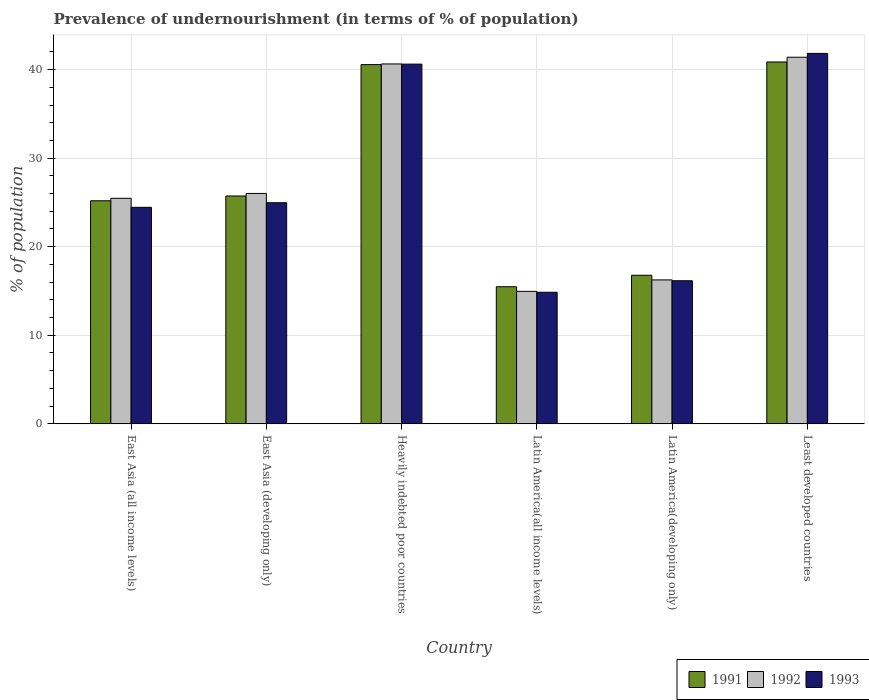How many different coloured bars are there?
Make the answer very short. 3. Are the number of bars on each tick of the X-axis equal?
Provide a short and direct response. Yes. What is the label of the 4th group of bars from the left?
Provide a succinct answer. Latin America(all income levels). What is the percentage of undernourished population in 1991 in East Asia (developing only)?
Your response must be concise. 25.73. Across all countries, what is the maximum percentage of undernourished population in 1991?
Give a very brief answer. 40.86. Across all countries, what is the minimum percentage of undernourished population in 1991?
Your answer should be very brief. 15.48. In which country was the percentage of undernourished population in 1992 maximum?
Offer a terse response. Least developed countries. In which country was the percentage of undernourished population in 1991 minimum?
Provide a short and direct response. Latin America(all income levels). What is the total percentage of undernourished population in 1993 in the graph?
Offer a very short reply. 162.87. What is the difference between the percentage of undernourished population in 1991 in Latin America(all income levels) and that in Least developed countries?
Make the answer very short. -25.39. What is the difference between the percentage of undernourished population in 1991 in East Asia (all income levels) and the percentage of undernourished population in 1993 in East Asia (developing only)?
Give a very brief answer. 0.22. What is the average percentage of undernourished population in 1992 per country?
Offer a terse response. 27.45. What is the difference between the percentage of undernourished population of/in 1991 and percentage of undernourished population of/in 1992 in Least developed countries?
Offer a very short reply. -0.54. What is the ratio of the percentage of undernourished population in 1992 in Heavily indebted poor countries to that in Latin America(developing only)?
Offer a very short reply. 2.5. Is the percentage of undernourished population in 1993 in East Asia (developing only) less than that in Latin America(all income levels)?
Ensure brevity in your answer.  No. Is the difference between the percentage of undernourished population in 1991 in East Asia (all income levels) and Heavily indebted poor countries greater than the difference between the percentage of undernourished population in 1992 in East Asia (all income levels) and Heavily indebted poor countries?
Provide a short and direct response. No. What is the difference between the highest and the second highest percentage of undernourished population in 1992?
Offer a very short reply. -0.76. What is the difference between the highest and the lowest percentage of undernourished population in 1993?
Offer a terse response. 26.98. Is the sum of the percentage of undernourished population in 1992 in Latin America(developing only) and Least developed countries greater than the maximum percentage of undernourished population in 1993 across all countries?
Ensure brevity in your answer.  Yes. What does the 2nd bar from the left in East Asia (all income levels) represents?
Provide a succinct answer. 1992. What does the 1st bar from the right in Heavily indebted poor countries represents?
Your response must be concise. 1993. How many bars are there?
Your answer should be very brief. 18. How many countries are there in the graph?
Make the answer very short. 6. Does the graph contain grids?
Your response must be concise. Yes. How many legend labels are there?
Provide a short and direct response. 3. What is the title of the graph?
Offer a very short reply. Prevalence of undernourishment (in terms of % of population). Does "2009" appear as one of the legend labels in the graph?
Ensure brevity in your answer.  No. What is the label or title of the X-axis?
Offer a terse response. Country. What is the label or title of the Y-axis?
Offer a very short reply. % of population. What is the % of population of 1991 in East Asia (all income levels)?
Offer a very short reply. 25.19. What is the % of population in 1992 in East Asia (all income levels)?
Provide a short and direct response. 25.47. What is the % of population of 1993 in East Asia (all income levels)?
Offer a terse response. 24.45. What is the % of population in 1991 in East Asia (developing only)?
Your answer should be very brief. 25.73. What is the % of population in 1992 in East Asia (developing only)?
Make the answer very short. 26.01. What is the % of population in 1993 in East Asia (developing only)?
Your response must be concise. 24.97. What is the % of population of 1991 in Heavily indebted poor countries?
Your response must be concise. 40.57. What is the % of population in 1992 in Heavily indebted poor countries?
Give a very brief answer. 40.64. What is the % of population of 1993 in Heavily indebted poor countries?
Give a very brief answer. 40.62. What is the % of population in 1991 in Latin America(all income levels)?
Your answer should be compact. 15.48. What is the % of population of 1992 in Latin America(all income levels)?
Make the answer very short. 14.96. What is the % of population in 1993 in Latin America(all income levels)?
Keep it short and to the point. 14.85. What is the % of population of 1991 in Latin America(developing only)?
Give a very brief answer. 16.77. What is the % of population of 1992 in Latin America(developing only)?
Your answer should be very brief. 16.25. What is the % of population of 1993 in Latin America(developing only)?
Provide a succinct answer. 16.15. What is the % of population in 1991 in Least developed countries?
Offer a very short reply. 40.86. What is the % of population in 1992 in Least developed countries?
Ensure brevity in your answer.  41.4. What is the % of population in 1993 in Least developed countries?
Keep it short and to the point. 41.83. Across all countries, what is the maximum % of population in 1991?
Offer a very short reply. 40.86. Across all countries, what is the maximum % of population of 1992?
Offer a very short reply. 41.4. Across all countries, what is the maximum % of population of 1993?
Provide a short and direct response. 41.83. Across all countries, what is the minimum % of population in 1991?
Ensure brevity in your answer.  15.48. Across all countries, what is the minimum % of population in 1992?
Your answer should be compact. 14.96. Across all countries, what is the minimum % of population in 1993?
Keep it short and to the point. 14.85. What is the total % of population in 1991 in the graph?
Keep it short and to the point. 164.6. What is the total % of population of 1992 in the graph?
Make the answer very short. 164.73. What is the total % of population in 1993 in the graph?
Offer a very short reply. 162.87. What is the difference between the % of population in 1991 in East Asia (all income levels) and that in East Asia (developing only)?
Ensure brevity in your answer.  -0.54. What is the difference between the % of population of 1992 in East Asia (all income levels) and that in East Asia (developing only)?
Your response must be concise. -0.55. What is the difference between the % of population in 1993 in East Asia (all income levels) and that in East Asia (developing only)?
Your answer should be very brief. -0.52. What is the difference between the % of population of 1991 in East Asia (all income levels) and that in Heavily indebted poor countries?
Your response must be concise. -15.38. What is the difference between the % of population in 1992 in East Asia (all income levels) and that in Heavily indebted poor countries?
Keep it short and to the point. -15.18. What is the difference between the % of population in 1993 in East Asia (all income levels) and that in Heavily indebted poor countries?
Keep it short and to the point. -16.18. What is the difference between the % of population in 1991 in East Asia (all income levels) and that in Latin America(all income levels)?
Offer a terse response. 9.71. What is the difference between the % of population of 1992 in East Asia (all income levels) and that in Latin America(all income levels)?
Offer a very short reply. 10.51. What is the difference between the % of population of 1993 in East Asia (all income levels) and that in Latin America(all income levels)?
Give a very brief answer. 9.6. What is the difference between the % of population of 1991 in East Asia (all income levels) and that in Latin America(developing only)?
Ensure brevity in your answer.  8.41. What is the difference between the % of population of 1992 in East Asia (all income levels) and that in Latin America(developing only)?
Provide a short and direct response. 9.22. What is the difference between the % of population of 1993 in East Asia (all income levels) and that in Latin America(developing only)?
Offer a terse response. 8.29. What is the difference between the % of population of 1991 in East Asia (all income levels) and that in Least developed countries?
Give a very brief answer. -15.68. What is the difference between the % of population of 1992 in East Asia (all income levels) and that in Least developed countries?
Ensure brevity in your answer.  -15.94. What is the difference between the % of population of 1993 in East Asia (all income levels) and that in Least developed countries?
Provide a short and direct response. -17.39. What is the difference between the % of population of 1991 in East Asia (developing only) and that in Heavily indebted poor countries?
Make the answer very short. -14.84. What is the difference between the % of population in 1992 in East Asia (developing only) and that in Heavily indebted poor countries?
Your response must be concise. -14.63. What is the difference between the % of population in 1993 in East Asia (developing only) and that in Heavily indebted poor countries?
Ensure brevity in your answer.  -15.66. What is the difference between the % of population of 1991 in East Asia (developing only) and that in Latin America(all income levels)?
Offer a terse response. 10.25. What is the difference between the % of population of 1992 in East Asia (developing only) and that in Latin America(all income levels)?
Your answer should be very brief. 11.06. What is the difference between the % of population in 1993 in East Asia (developing only) and that in Latin America(all income levels)?
Your answer should be very brief. 10.11. What is the difference between the % of population in 1991 in East Asia (developing only) and that in Latin America(developing only)?
Give a very brief answer. 8.95. What is the difference between the % of population of 1992 in East Asia (developing only) and that in Latin America(developing only)?
Offer a very short reply. 9.77. What is the difference between the % of population of 1993 in East Asia (developing only) and that in Latin America(developing only)?
Give a very brief answer. 8.81. What is the difference between the % of population in 1991 in East Asia (developing only) and that in Least developed countries?
Your response must be concise. -15.14. What is the difference between the % of population in 1992 in East Asia (developing only) and that in Least developed countries?
Make the answer very short. -15.39. What is the difference between the % of population in 1993 in East Asia (developing only) and that in Least developed countries?
Offer a very short reply. -16.87. What is the difference between the % of population of 1991 in Heavily indebted poor countries and that in Latin America(all income levels)?
Your answer should be very brief. 25.09. What is the difference between the % of population of 1992 in Heavily indebted poor countries and that in Latin America(all income levels)?
Ensure brevity in your answer.  25.69. What is the difference between the % of population in 1993 in Heavily indebted poor countries and that in Latin America(all income levels)?
Keep it short and to the point. 25.77. What is the difference between the % of population of 1991 in Heavily indebted poor countries and that in Latin America(developing only)?
Make the answer very short. 23.8. What is the difference between the % of population in 1992 in Heavily indebted poor countries and that in Latin America(developing only)?
Provide a succinct answer. 24.4. What is the difference between the % of population in 1993 in Heavily indebted poor countries and that in Latin America(developing only)?
Offer a very short reply. 24.47. What is the difference between the % of population in 1991 in Heavily indebted poor countries and that in Least developed countries?
Provide a succinct answer. -0.3. What is the difference between the % of population in 1992 in Heavily indebted poor countries and that in Least developed countries?
Keep it short and to the point. -0.76. What is the difference between the % of population in 1993 in Heavily indebted poor countries and that in Least developed countries?
Offer a very short reply. -1.21. What is the difference between the % of population of 1991 in Latin America(all income levels) and that in Latin America(developing only)?
Ensure brevity in your answer.  -1.3. What is the difference between the % of population of 1992 in Latin America(all income levels) and that in Latin America(developing only)?
Your response must be concise. -1.29. What is the difference between the % of population of 1993 in Latin America(all income levels) and that in Latin America(developing only)?
Your response must be concise. -1.3. What is the difference between the % of population of 1991 in Latin America(all income levels) and that in Least developed countries?
Your answer should be compact. -25.39. What is the difference between the % of population of 1992 in Latin America(all income levels) and that in Least developed countries?
Keep it short and to the point. -26.45. What is the difference between the % of population in 1993 in Latin America(all income levels) and that in Least developed countries?
Your answer should be very brief. -26.98. What is the difference between the % of population of 1991 in Latin America(developing only) and that in Least developed countries?
Offer a terse response. -24.09. What is the difference between the % of population in 1992 in Latin America(developing only) and that in Least developed countries?
Provide a short and direct response. -25.16. What is the difference between the % of population of 1993 in Latin America(developing only) and that in Least developed countries?
Offer a very short reply. -25.68. What is the difference between the % of population of 1991 in East Asia (all income levels) and the % of population of 1992 in East Asia (developing only)?
Keep it short and to the point. -0.83. What is the difference between the % of population of 1991 in East Asia (all income levels) and the % of population of 1993 in East Asia (developing only)?
Your answer should be compact. 0.22. What is the difference between the % of population of 1992 in East Asia (all income levels) and the % of population of 1993 in East Asia (developing only)?
Your response must be concise. 0.5. What is the difference between the % of population in 1991 in East Asia (all income levels) and the % of population in 1992 in Heavily indebted poor countries?
Ensure brevity in your answer.  -15.46. What is the difference between the % of population of 1991 in East Asia (all income levels) and the % of population of 1993 in Heavily indebted poor countries?
Make the answer very short. -15.44. What is the difference between the % of population of 1992 in East Asia (all income levels) and the % of population of 1993 in Heavily indebted poor countries?
Ensure brevity in your answer.  -15.16. What is the difference between the % of population in 1991 in East Asia (all income levels) and the % of population in 1992 in Latin America(all income levels)?
Give a very brief answer. 10.23. What is the difference between the % of population of 1991 in East Asia (all income levels) and the % of population of 1993 in Latin America(all income levels)?
Give a very brief answer. 10.33. What is the difference between the % of population of 1992 in East Asia (all income levels) and the % of population of 1993 in Latin America(all income levels)?
Your answer should be very brief. 10.62. What is the difference between the % of population in 1991 in East Asia (all income levels) and the % of population in 1992 in Latin America(developing only)?
Your response must be concise. 8.94. What is the difference between the % of population in 1991 in East Asia (all income levels) and the % of population in 1993 in Latin America(developing only)?
Provide a short and direct response. 9.03. What is the difference between the % of population in 1992 in East Asia (all income levels) and the % of population in 1993 in Latin America(developing only)?
Your response must be concise. 9.31. What is the difference between the % of population of 1991 in East Asia (all income levels) and the % of population of 1992 in Least developed countries?
Give a very brief answer. -16.22. What is the difference between the % of population in 1991 in East Asia (all income levels) and the % of population in 1993 in Least developed countries?
Your response must be concise. -16.65. What is the difference between the % of population in 1992 in East Asia (all income levels) and the % of population in 1993 in Least developed countries?
Ensure brevity in your answer.  -16.37. What is the difference between the % of population in 1991 in East Asia (developing only) and the % of population in 1992 in Heavily indebted poor countries?
Make the answer very short. -14.91. What is the difference between the % of population in 1991 in East Asia (developing only) and the % of population in 1993 in Heavily indebted poor countries?
Your answer should be compact. -14.9. What is the difference between the % of population of 1992 in East Asia (developing only) and the % of population of 1993 in Heavily indebted poor countries?
Offer a very short reply. -14.61. What is the difference between the % of population of 1991 in East Asia (developing only) and the % of population of 1992 in Latin America(all income levels)?
Your answer should be very brief. 10.77. What is the difference between the % of population in 1991 in East Asia (developing only) and the % of population in 1993 in Latin America(all income levels)?
Your answer should be very brief. 10.88. What is the difference between the % of population in 1992 in East Asia (developing only) and the % of population in 1993 in Latin America(all income levels)?
Ensure brevity in your answer.  11.16. What is the difference between the % of population of 1991 in East Asia (developing only) and the % of population of 1992 in Latin America(developing only)?
Your answer should be very brief. 9.48. What is the difference between the % of population of 1991 in East Asia (developing only) and the % of population of 1993 in Latin America(developing only)?
Make the answer very short. 9.58. What is the difference between the % of population in 1992 in East Asia (developing only) and the % of population in 1993 in Latin America(developing only)?
Give a very brief answer. 9.86. What is the difference between the % of population in 1991 in East Asia (developing only) and the % of population in 1992 in Least developed countries?
Offer a terse response. -15.67. What is the difference between the % of population of 1991 in East Asia (developing only) and the % of population of 1993 in Least developed countries?
Ensure brevity in your answer.  -16.11. What is the difference between the % of population in 1992 in East Asia (developing only) and the % of population in 1993 in Least developed countries?
Ensure brevity in your answer.  -15.82. What is the difference between the % of population in 1991 in Heavily indebted poor countries and the % of population in 1992 in Latin America(all income levels)?
Give a very brief answer. 25.61. What is the difference between the % of population of 1991 in Heavily indebted poor countries and the % of population of 1993 in Latin America(all income levels)?
Your response must be concise. 25.72. What is the difference between the % of population of 1992 in Heavily indebted poor countries and the % of population of 1993 in Latin America(all income levels)?
Provide a succinct answer. 25.79. What is the difference between the % of population of 1991 in Heavily indebted poor countries and the % of population of 1992 in Latin America(developing only)?
Keep it short and to the point. 24.32. What is the difference between the % of population of 1991 in Heavily indebted poor countries and the % of population of 1993 in Latin America(developing only)?
Keep it short and to the point. 24.42. What is the difference between the % of population of 1992 in Heavily indebted poor countries and the % of population of 1993 in Latin America(developing only)?
Ensure brevity in your answer.  24.49. What is the difference between the % of population of 1991 in Heavily indebted poor countries and the % of population of 1992 in Least developed countries?
Give a very brief answer. -0.83. What is the difference between the % of population in 1991 in Heavily indebted poor countries and the % of population in 1993 in Least developed countries?
Ensure brevity in your answer.  -1.27. What is the difference between the % of population of 1992 in Heavily indebted poor countries and the % of population of 1993 in Least developed countries?
Give a very brief answer. -1.19. What is the difference between the % of population in 1991 in Latin America(all income levels) and the % of population in 1992 in Latin America(developing only)?
Your response must be concise. -0.77. What is the difference between the % of population of 1991 in Latin America(all income levels) and the % of population of 1993 in Latin America(developing only)?
Offer a terse response. -0.68. What is the difference between the % of population in 1992 in Latin America(all income levels) and the % of population in 1993 in Latin America(developing only)?
Your response must be concise. -1.2. What is the difference between the % of population of 1991 in Latin America(all income levels) and the % of population of 1992 in Least developed countries?
Your answer should be very brief. -25.93. What is the difference between the % of population in 1991 in Latin America(all income levels) and the % of population in 1993 in Least developed countries?
Keep it short and to the point. -26.36. What is the difference between the % of population of 1992 in Latin America(all income levels) and the % of population of 1993 in Least developed countries?
Offer a terse response. -26.88. What is the difference between the % of population of 1991 in Latin America(developing only) and the % of population of 1992 in Least developed countries?
Make the answer very short. -24.63. What is the difference between the % of population of 1991 in Latin America(developing only) and the % of population of 1993 in Least developed countries?
Provide a short and direct response. -25.06. What is the difference between the % of population in 1992 in Latin America(developing only) and the % of population in 1993 in Least developed countries?
Make the answer very short. -25.59. What is the average % of population of 1991 per country?
Your response must be concise. 27.43. What is the average % of population of 1992 per country?
Keep it short and to the point. 27.45. What is the average % of population of 1993 per country?
Keep it short and to the point. 27.15. What is the difference between the % of population of 1991 and % of population of 1992 in East Asia (all income levels)?
Ensure brevity in your answer.  -0.28. What is the difference between the % of population of 1991 and % of population of 1993 in East Asia (all income levels)?
Your response must be concise. 0.74. What is the difference between the % of population of 1991 and % of population of 1992 in East Asia (developing only)?
Offer a terse response. -0.29. What is the difference between the % of population of 1991 and % of population of 1993 in East Asia (developing only)?
Your answer should be very brief. 0.76. What is the difference between the % of population in 1992 and % of population in 1993 in East Asia (developing only)?
Give a very brief answer. 1.05. What is the difference between the % of population of 1991 and % of population of 1992 in Heavily indebted poor countries?
Your answer should be compact. -0.07. What is the difference between the % of population of 1991 and % of population of 1993 in Heavily indebted poor countries?
Your response must be concise. -0.05. What is the difference between the % of population in 1992 and % of population in 1993 in Heavily indebted poor countries?
Ensure brevity in your answer.  0.02. What is the difference between the % of population in 1991 and % of population in 1992 in Latin America(all income levels)?
Ensure brevity in your answer.  0.52. What is the difference between the % of population in 1991 and % of population in 1993 in Latin America(all income levels)?
Your response must be concise. 0.62. What is the difference between the % of population of 1992 and % of population of 1993 in Latin America(all income levels)?
Provide a short and direct response. 0.1. What is the difference between the % of population in 1991 and % of population in 1992 in Latin America(developing only)?
Offer a terse response. 0.53. What is the difference between the % of population of 1991 and % of population of 1993 in Latin America(developing only)?
Provide a short and direct response. 0.62. What is the difference between the % of population of 1992 and % of population of 1993 in Latin America(developing only)?
Give a very brief answer. 0.09. What is the difference between the % of population in 1991 and % of population in 1992 in Least developed countries?
Offer a terse response. -0.54. What is the difference between the % of population in 1991 and % of population in 1993 in Least developed countries?
Keep it short and to the point. -0.97. What is the difference between the % of population of 1992 and % of population of 1993 in Least developed countries?
Ensure brevity in your answer.  -0.43. What is the ratio of the % of population of 1991 in East Asia (all income levels) to that in East Asia (developing only)?
Your answer should be very brief. 0.98. What is the ratio of the % of population in 1992 in East Asia (all income levels) to that in East Asia (developing only)?
Ensure brevity in your answer.  0.98. What is the ratio of the % of population of 1993 in East Asia (all income levels) to that in East Asia (developing only)?
Make the answer very short. 0.98. What is the ratio of the % of population of 1991 in East Asia (all income levels) to that in Heavily indebted poor countries?
Keep it short and to the point. 0.62. What is the ratio of the % of population of 1992 in East Asia (all income levels) to that in Heavily indebted poor countries?
Your answer should be very brief. 0.63. What is the ratio of the % of population of 1993 in East Asia (all income levels) to that in Heavily indebted poor countries?
Your answer should be compact. 0.6. What is the ratio of the % of population of 1991 in East Asia (all income levels) to that in Latin America(all income levels)?
Provide a short and direct response. 1.63. What is the ratio of the % of population of 1992 in East Asia (all income levels) to that in Latin America(all income levels)?
Your answer should be very brief. 1.7. What is the ratio of the % of population in 1993 in East Asia (all income levels) to that in Latin America(all income levels)?
Your answer should be very brief. 1.65. What is the ratio of the % of population of 1991 in East Asia (all income levels) to that in Latin America(developing only)?
Ensure brevity in your answer.  1.5. What is the ratio of the % of population of 1992 in East Asia (all income levels) to that in Latin America(developing only)?
Your answer should be very brief. 1.57. What is the ratio of the % of population of 1993 in East Asia (all income levels) to that in Latin America(developing only)?
Give a very brief answer. 1.51. What is the ratio of the % of population of 1991 in East Asia (all income levels) to that in Least developed countries?
Provide a short and direct response. 0.62. What is the ratio of the % of population of 1992 in East Asia (all income levels) to that in Least developed countries?
Make the answer very short. 0.62. What is the ratio of the % of population in 1993 in East Asia (all income levels) to that in Least developed countries?
Ensure brevity in your answer.  0.58. What is the ratio of the % of population of 1991 in East Asia (developing only) to that in Heavily indebted poor countries?
Your answer should be very brief. 0.63. What is the ratio of the % of population of 1992 in East Asia (developing only) to that in Heavily indebted poor countries?
Provide a short and direct response. 0.64. What is the ratio of the % of population in 1993 in East Asia (developing only) to that in Heavily indebted poor countries?
Your answer should be very brief. 0.61. What is the ratio of the % of population of 1991 in East Asia (developing only) to that in Latin America(all income levels)?
Ensure brevity in your answer.  1.66. What is the ratio of the % of population of 1992 in East Asia (developing only) to that in Latin America(all income levels)?
Offer a very short reply. 1.74. What is the ratio of the % of population in 1993 in East Asia (developing only) to that in Latin America(all income levels)?
Your answer should be compact. 1.68. What is the ratio of the % of population of 1991 in East Asia (developing only) to that in Latin America(developing only)?
Offer a very short reply. 1.53. What is the ratio of the % of population of 1992 in East Asia (developing only) to that in Latin America(developing only)?
Make the answer very short. 1.6. What is the ratio of the % of population in 1993 in East Asia (developing only) to that in Latin America(developing only)?
Make the answer very short. 1.55. What is the ratio of the % of population of 1991 in East Asia (developing only) to that in Least developed countries?
Provide a short and direct response. 0.63. What is the ratio of the % of population in 1992 in East Asia (developing only) to that in Least developed countries?
Your answer should be very brief. 0.63. What is the ratio of the % of population of 1993 in East Asia (developing only) to that in Least developed countries?
Give a very brief answer. 0.6. What is the ratio of the % of population of 1991 in Heavily indebted poor countries to that in Latin America(all income levels)?
Make the answer very short. 2.62. What is the ratio of the % of population in 1992 in Heavily indebted poor countries to that in Latin America(all income levels)?
Your answer should be very brief. 2.72. What is the ratio of the % of population in 1993 in Heavily indebted poor countries to that in Latin America(all income levels)?
Make the answer very short. 2.74. What is the ratio of the % of population in 1991 in Heavily indebted poor countries to that in Latin America(developing only)?
Ensure brevity in your answer.  2.42. What is the ratio of the % of population in 1992 in Heavily indebted poor countries to that in Latin America(developing only)?
Offer a terse response. 2.5. What is the ratio of the % of population of 1993 in Heavily indebted poor countries to that in Latin America(developing only)?
Your answer should be compact. 2.52. What is the ratio of the % of population in 1991 in Heavily indebted poor countries to that in Least developed countries?
Give a very brief answer. 0.99. What is the ratio of the % of population of 1992 in Heavily indebted poor countries to that in Least developed countries?
Your answer should be compact. 0.98. What is the ratio of the % of population in 1993 in Heavily indebted poor countries to that in Least developed countries?
Provide a short and direct response. 0.97. What is the ratio of the % of population in 1991 in Latin America(all income levels) to that in Latin America(developing only)?
Give a very brief answer. 0.92. What is the ratio of the % of population in 1992 in Latin America(all income levels) to that in Latin America(developing only)?
Provide a succinct answer. 0.92. What is the ratio of the % of population of 1993 in Latin America(all income levels) to that in Latin America(developing only)?
Provide a short and direct response. 0.92. What is the ratio of the % of population of 1991 in Latin America(all income levels) to that in Least developed countries?
Offer a terse response. 0.38. What is the ratio of the % of population of 1992 in Latin America(all income levels) to that in Least developed countries?
Offer a very short reply. 0.36. What is the ratio of the % of population of 1993 in Latin America(all income levels) to that in Least developed countries?
Your response must be concise. 0.35. What is the ratio of the % of population of 1991 in Latin America(developing only) to that in Least developed countries?
Offer a very short reply. 0.41. What is the ratio of the % of population in 1992 in Latin America(developing only) to that in Least developed countries?
Provide a short and direct response. 0.39. What is the ratio of the % of population of 1993 in Latin America(developing only) to that in Least developed countries?
Offer a terse response. 0.39. What is the difference between the highest and the second highest % of population of 1991?
Provide a short and direct response. 0.3. What is the difference between the highest and the second highest % of population in 1992?
Your answer should be very brief. 0.76. What is the difference between the highest and the second highest % of population in 1993?
Provide a succinct answer. 1.21. What is the difference between the highest and the lowest % of population in 1991?
Offer a terse response. 25.39. What is the difference between the highest and the lowest % of population of 1992?
Offer a very short reply. 26.45. What is the difference between the highest and the lowest % of population in 1993?
Your response must be concise. 26.98. 